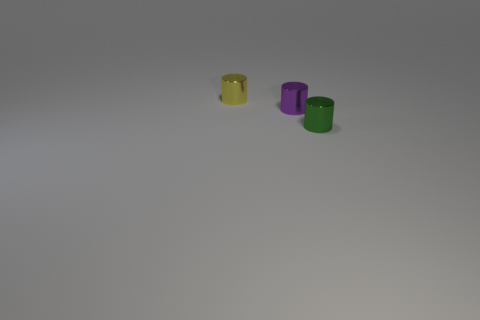Subtract 1 cylinders. How many cylinders are left? 2 Add 1 green things. How many objects exist? 4 Subtract 0 red cylinders. How many objects are left? 3 Subtract all tiny purple metallic things. Subtract all purple cylinders. How many objects are left? 1 Add 3 yellow metal objects. How many yellow metal objects are left? 4 Add 1 small cyan rubber spheres. How many small cyan rubber spheres exist? 1 